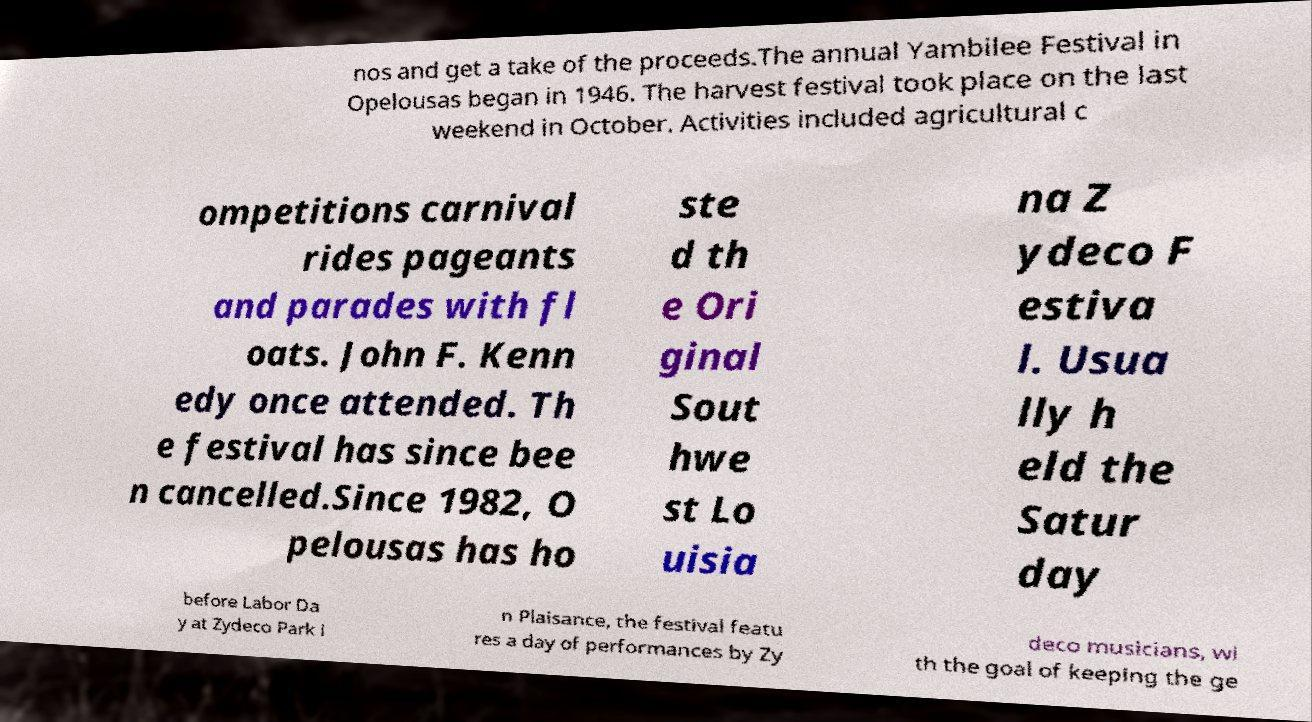What messages or text are displayed in this image? I need them in a readable, typed format. nos and get a take of the proceeds.The annual Yambilee Festival in Opelousas began in 1946. The harvest festival took place on the last weekend in October. Activities included agricultural c ompetitions carnival rides pageants and parades with fl oats. John F. Kenn edy once attended. Th e festival has since bee n cancelled.Since 1982, O pelousas has ho ste d th e Ori ginal Sout hwe st Lo uisia na Z ydeco F estiva l. Usua lly h eld the Satur day before Labor Da y at Zydeco Park i n Plaisance, the festival featu res a day of performances by Zy deco musicians, wi th the goal of keeping the ge 